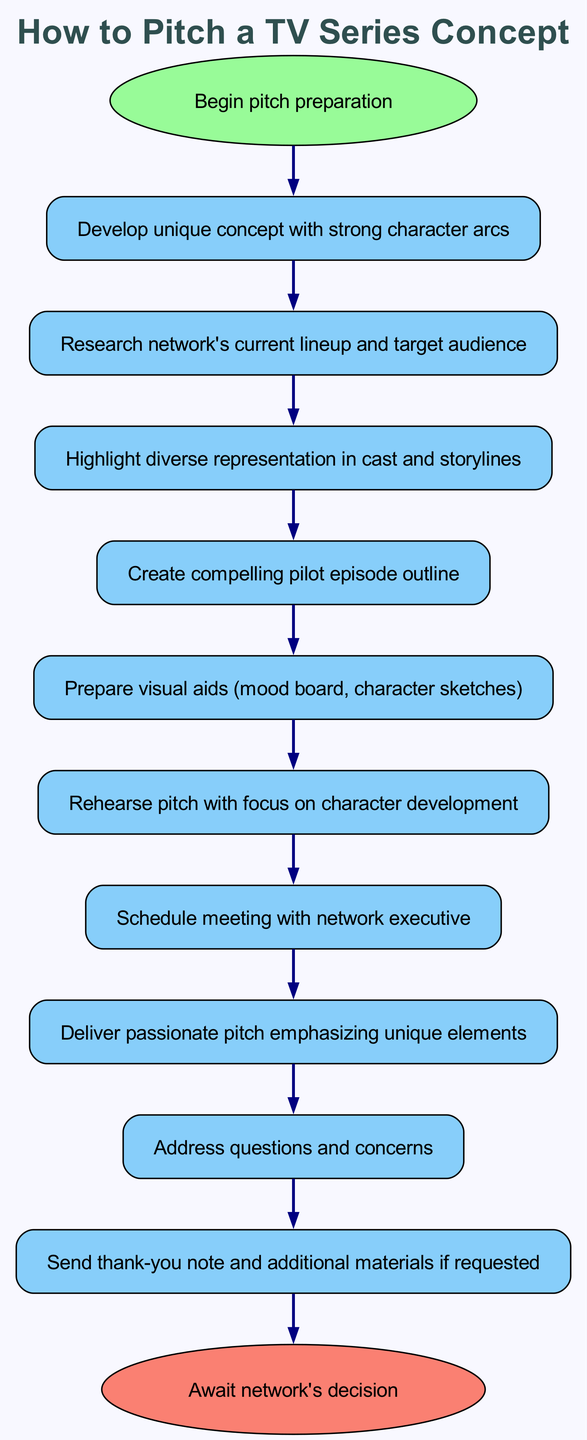What is the first step in the pitch preparation process? The diagram indicates that the first step is "Begin pitch preparation," which is represented at the start of the flow chart.
Answer: Begin pitch preparation How many nodes are present in this diagram? By counting each individual step and start/end points in the flow chart, there are a total of 12 nodes.
Answer: 12 What comes after "Research network's current lineup and target audience"? Following "Research network's current lineup and target audience," the next step is "Highlight diverse representation in cast and storylines," which directly follows in the flow of the chart.
Answer: Highlight diverse representation in cast and storylines Which step emphasizes character development during the pitch practice? The step labeled "Rehearse pitch with focus on character development" specifically indicates that character development is a focal point of practice prior to the pitch.
Answer: Rehearse pitch with focus on character development What action follows the delivery of the pitch? After delivering the pitch, the next action is "Address questions and concerns," according to the flow of the diagram.
Answer: Address questions and concerns What is the last action taken in the pitching process? The final action in the process, as depicted in the flow chart, is "Await network's decision," which concludes the series of steps for pitching.
Answer: Await network's decision How many edges connect the nodes in this flow chart? By counting the connections between the nodes in the diagram, there are a total of 11 edges that represent the flow from one step to the next.
Answer: 11 Which node directly connects the "Create compelling pilot episode outline" node? The node "Create compelling pilot episode outline" is directly connected to the node "Prepare visual aids (mood board, character sketches)," showing the next step in the process.
Answer: Prepare visual aids (mood board, character sketches) What is the main focus when practicing the pitch? The diagram clearly states that the main focus when practicing the pitch should be on character development, which is highlighted in the corresponding step.
Answer: Character development 